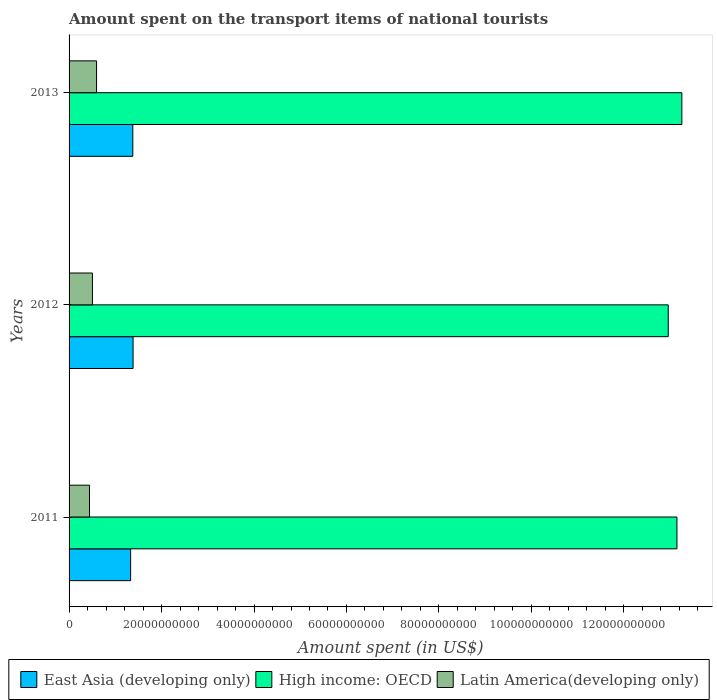How many groups of bars are there?
Your answer should be compact. 3. How many bars are there on the 2nd tick from the top?
Ensure brevity in your answer.  3. What is the label of the 2nd group of bars from the top?
Your response must be concise. 2012. What is the amount spent on the transport items of national tourists in Latin America(developing only) in 2011?
Ensure brevity in your answer.  4.42e+09. Across all years, what is the maximum amount spent on the transport items of national tourists in Latin America(developing only)?
Provide a short and direct response. 5.95e+09. Across all years, what is the minimum amount spent on the transport items of national tourists in East Asia (developing only)?
Your response must be concise. 1.33e+1. In which year was the amount spent on the transport items of national tourists in High income: OECD minimum?
Offer a terse response. 2012. What is the total amount spent on the transport items of national tourists in High income: OECD in the graph?
Your answer should be compact. 3.94e+11. What is the difference between the amount spent on the transport items of national tourists in Latin America(developing only) in 2012 and that in 2013?
Give a very brief answer. -8.94e+08. What is the difference between the amount spent on the transport items of national tourists in Latin America(developing only) in 2011 and the amount spent on the transport items of national tourists in East Asia (developing only) in 2012?
Keep it short and to the point. -9.42e+09. What is the average amount spent on the transport items of national tourists in Latin America(developing only) per year?
Offer a very short reply. 5.14e+09. In the year 2013, what is the difference between the amount spent on the transport items of national tourists in East Asia (developing only) and amount spent on the transport items of national tourists in High income: OECD?
Provide a succinct answer. -1.19e+11. In how many years, is the amount spent on the transport items of national tourists in Latin America(developing only) greater than 40000000000 US$?
Your response must be concise. 0. What is the ratio of the amount spent on the transport items of national tourists in East Asia (developing only) in 2011 to that in 2012?
Give a very brief answer. 0.96. Is the difference between the amount spent on the transport items of national tourists in East Asia (developing only) in 2011 and 2013 greater than the difference between the amount spent on the transport items of national tourists in High income: OECD in 2011 and 2013?
Your answer should be very brief. Yes. What is the difference between the highest and the second highest amount spent on the transport items of national tourists in High income: OECD?
Keep it short and to the point. 1.06e+09. What is the difference between the highest and the lowest amount spent on the transport items of national tourists in High income: OECD?
Your response must be concise. 2.95e+09. In how many years, is the amount spent on the transport items of national tourists in Latin America(developing only) greater than the average amount spent on the transport items of national tourists in Latin America(developing only) taken over all years?
Make the answer very short. 1. Is the sum of the amount spent on the transport items of national tourists in Latin America(developing only) in 2011 and 2013 greater than the maximum amount spent on the transport items of national tourists in East Asia (developing only) across all years?
Provide a succinct answer. No. What does the 2nd bar from the top in 2012 represents?
Offer a terse response. High income: OECD. What does the 3rd bar from the bottom in 2013 represents?
Offer a terse response. Latin America(developing only). Is it the case that in every year, the sum of the amount spent on the transport items of national tourists in Latin America(developing only) and amount spent on the transport items of national tourists in High income: OECD is greater than the amount spent on the transport items of national tourists in East Asia (developing only)?
Provide a short and direct response. Yes. Are all the bars in the graph horizontal?
Provide a succinct answer. Yes. How many years are there in the graph?
Provide a succinct answer. 3. What is the difference between two consecutive major ticks on the X-axis?
Offer a terse response. 2.00e+1. Are the values on the major ticks of X-axis written in scientific E-notation?
Offer a terse response. No. Does the graph contain any zero values?
Make the answer very short. No. How many legend labels are there?
Make the answer very short. 3. How are the legend labels stacked?
Provide a succinct answer. Horizontal. What is the title of the graph?
Ensure brevity in your answer.  Amount spent on the transport items of national tourists. Does "Ireland" appear as one of the legend labels in the graph?
Keep it short and to the point. No. What is the label or title of the X-axis?
Make the answer very short. Amount spent (in US$). What is the Amount spent (in US$) in East Asia (developing only) in 2011?
Your answer should be compact. 1.33e+1. What is the Amount spent (in US$) in High income: OECD in 2011?
Your response must be concise. 1.31e+11. What is the Amount spent (in US$) of Latin America(developing only) in 2011?
Ensure brevity in your answer.  4.42e+09. What is the Amount spent (in US$) in East Asia (developing only) in 2012?
Provide a short and direct response. 1.38e+1. What is the Amount spent (in US$) in High income: OECD in 2012?
Ensure brevity in your answer.  1.30e+11. What is the Amount spent (in US$) of Latin America(developing only) in 2012?
Your answer should be compact. 5.05e+09. What is the Amount spent (in US$) of East Asia (developing only) in 2013?
Provide a short and direct response. 1.38e+1. What is the Amount spent (in US$) of High income: OECD in 2013?
Your answer should be compact. 1.33e+11. What is the Amount spent (in US$) of Latin America(developing only) in 2013?
Provide a succinct answer. 5.95e+09. Across all years, what is the maximum Amount spent (in US$) of East Asia (developing only)?
Offer a very short reply. 1.38e+1. Across all years, what is the maximum Amount spent (in US$) of High income: OECD?
Your answer should be compact. 1.33e+11. Across all years, what is the maximum Amount spent (in US$) of Latin America(developing only)?
Keep it short and to the point. 5.95e+09. Across all years, what is the minimum Amount spent (in US$) in East Asia (developing only)?
Your answer should be compact. 1.33e+1. Across all years, what is the minimum Amount spent (in US$) in High income: OECD?
Provide a succinct answer. 1.30e+11. Across all years, what is the minimum Amount spent (in US$) in Latin America(developing only)?
Give a very brief answer. 4.42e+09. What is the total Amount spent (in US$) in East Asia (developing only) in the graph?
Keep it short and to the point. 4.09e+1. What is the total Amount spent (in US$) in High income: OECD in the graph?
Make the answer very short. 3.94e+11. What is the total Amount spent (in US$) in Latin America(developing only) in the graph?
Provide a short and direct response. 1.54e+1. What is the difference between the Amount spent (in US$) in East Asia (developing only) in 2011 and that in 2012?
Offer a terse response. -5.30e+08. What is the difference between the Amount spent (in US$) in High income: OECD in 2011 and that in 2012?
Provide a succinct answer. 1.88e+09. What is the difference between the Amount spent (in US$) of Latin America(developing only) in 2011 and that in 2012?
Your answer should be compact. -6.31e+08. What is the difference between the Amount spent (in US$) of East Asia (developing only) in 2011 and that in 2013?
Your answer should be very brief. -4.72e+08. What is the difference between the Amount spent (in US$) in High income: OECD in 2011 and that in 2013?
Offer a very short reply. -1.06e+09. What is the difference between the Amount spent (in US$) of Latin America(developing only) in 2011 and that in 2013?
Provide a short and direct response. -1.53e+09. What is the difference between the Amount spent (in US$) in East Asia (developing only) in 2012 and that in 2013?
Give a very brief answer. 5.86e+07. What is the difference between the Amount spent (in US$) in High income: OECD in 2012 and that in 2013?
Provide a short and direct response. -2.95e+09. What is the difference between the Amount spent (in US$) of Latin America(developing only) in 2012 and that in 2013?
Ensure brevity in your answer.  -8.94e+08. What is the difference between the Amount spent (in US$) in East Asia (developing only) in 2011 and the Amount spent (in US$) in High income: OECD in 2012?
Make the answer very short. -1.16e+11. What is the difference between the Amount spent (in US$) of East Asia (developing only) in 2011 and the Amount spent (in US$) of Latin America(developing only) in 2012?
Keep it short and to the point. 8.26e+09. What is the difference between the Amount spent (in US$) of High income: OECD in 2011 and the Amount spent (in US$) of Latin America(developing only) in 2012?
Provide a succinct answer. 1.26e+11. What is the difference between the Amount spent (in US$) in East Asia (developing only) in 2011 and the Amount spent (in US$) in High income: OECD in 2013?
Keep it short and to the point. -1.19e+11. What is the difference between the Amount spent (in US$) in East Asia (developing only) in 2011 and the Amount spent (in US$) in Latin America(developing only) in 2013?
Keep it short and to the point. 7.37e+09. What is the difference between the Amount spent (in US$) of High income: OECD in 2011 and the Amount spent (in US$) of Latin America(developing only) in 2013?
Keep it short and to the point. 1.26e+11. What is the difference between the Amount spent (in US$) of East Asia (developing only) in 2012 and the Amount spent (in US$) of High income: OECD in 2013?
Give a very brief answer. -1.19e+11. What is the difference between the Amount spent (in US$) of East Asia (developing only) in 2012 and the Amount spent (in US$) of Latin America(developing only) in 2013?
Ensure brevity in your answer.  7.90e+09. What is the difference between the Amount spent (in US$) in High income: OECD in 2012 and the Amount spent (in US$) in Latin America(developing only) in 2013?
Give a very brief answer. 1.24e+11. What is the average Amount spent (in US$) in East Asia (developing only) per year?
Your response must be concise. 1.36e+1. What is the average Amount spent (in US$) in High income: OECD per year?
Keep it short and to the point. 1.31e+11. What is the average Amount spent (in US$) of Latin America(developing only) per year?
Keep it short and to the point. 5.14e+09. In the year 2011, what is the difference between the Amount spent (in US$) of East Asia (developing only) and Amount spent (in US$) of High income: OECD?
Your answer should be very brief. -1.18e+11. In the year 2011, what is the difference between the Amount spent (in US$) in East Asia (developing only) and Amount spent (in US$) in Latin America(developing only)?
Offer a very short reply. 8.89e+09. In the year 2011, what is the difference between the Amount spent (in US$) of High income: OECD and Amount spent (in US$) of Latin America(developing only)?
Offer a very short reply. 1.27e+11. In the year 2012, what is the difference between the Amount spent (in US$) of East Asia (developing only) and Amount spent (in US$) of High income: OECD?
Ensure brevity in your answer.  -1.16e+11. In the year 2012, what is the difference between the Amount spent (in US$) in East Asia (developing only) and Amount spent (in US$) in Latin America(developing only)?
Your answer should be very brief. 8.79e+09. In the year 2012, what is the difference between the Amount spent (in US$) of High income: OECD and Amount spent (in US$) of Latin America(developing only)?
Provide a succinct answer. 1.25e+11. In the year 2013, what is the difference between the Amount spent (in US$) in East Asia (developing only) and Amount spent (in US$) in High income: OECD?
Ensure brevity in your answer.  -1.19e+11. In the year 2013, what is the difference between the Amount spent (in US$) in East Asia (developing only) and Amount spent (in US$) in Latin America(developing only)?
Your answer should be compact. 7.84e+09. In the year 2013, what is the difference between the Amount spent (in US$) in High income: OECD and Amount spent (in US$) in Latin America(developing only)?
Make the answer very short. 1.27e+11. What is the ratio of the Amount spent (in US$) of East Asia (developing only) in 2011 to that in 2012?
Ensure brevity in your answer.  0.96. What is the ratio of the Amount spent (in US$) of High income: OECD in 2011 to that in 2012?
Give a very brief answer. 1.01. What is the ratio of the Amount spent (in US$) in Latin America(developing only) in 2011 to that in 2012?
Make the answer very short. 0.88. What is the ratio of the Amount spent (in US$) in East Asia (developing only) in 2011 to that in 2013?
Offer a terse response. 0.97. What is the ratio of the Amount spent (in US$) of High income: OECD in 2011 to that in 2013?
Keep it short and to the point. 0.99. What is the ratio of the Amount spent (in US$) of Latin America(developing only) in 2011 to that in 2013?
Give a very brief answer. 0.74. What is the ratio of the Amount spent (in US$) of East Asia (developing only) in 2012 to that in 2013?
Make the answer very short. 1. What is the ratio of the Amount spent (in US$) of High income: OECD in 2012 to that in 2013?
Ensure brevity in your answer.  0.98. What is the ratio of the Amount spent (in US$) in Latin America(developing only) in 2012 to that in 2013?
Offer a terse response. 0.85. What is the difference between the highest and the second highest Amount spent (in US$) in East Asia (developing only)?
Make the answer very short. 5.86e+07. What is the difference between the highest and the second highest Amount spent (in US$) in High income: OECD?
Offer a very short reply. 1.06e+09. What is the difference between the highest and the second highest Amount spent (in US$) in Latin America(developing only)?
Provide a short and direct response. 8.94e+08. What is the difference between the highest and the lowest Amount spent (in US$) in East Asia (developing only)?
Provide a short and direct response. 5.30e+08. What is the difference between the highest and the lowest Amount spent (in US$) of High income: OECD?
Your answer should be compact. 2.95e+09. What is the difference between the highest and the lowest Amount spent (in US$) in Latin America(developing only)?
Your answer should be compact. 1.53e+09. 